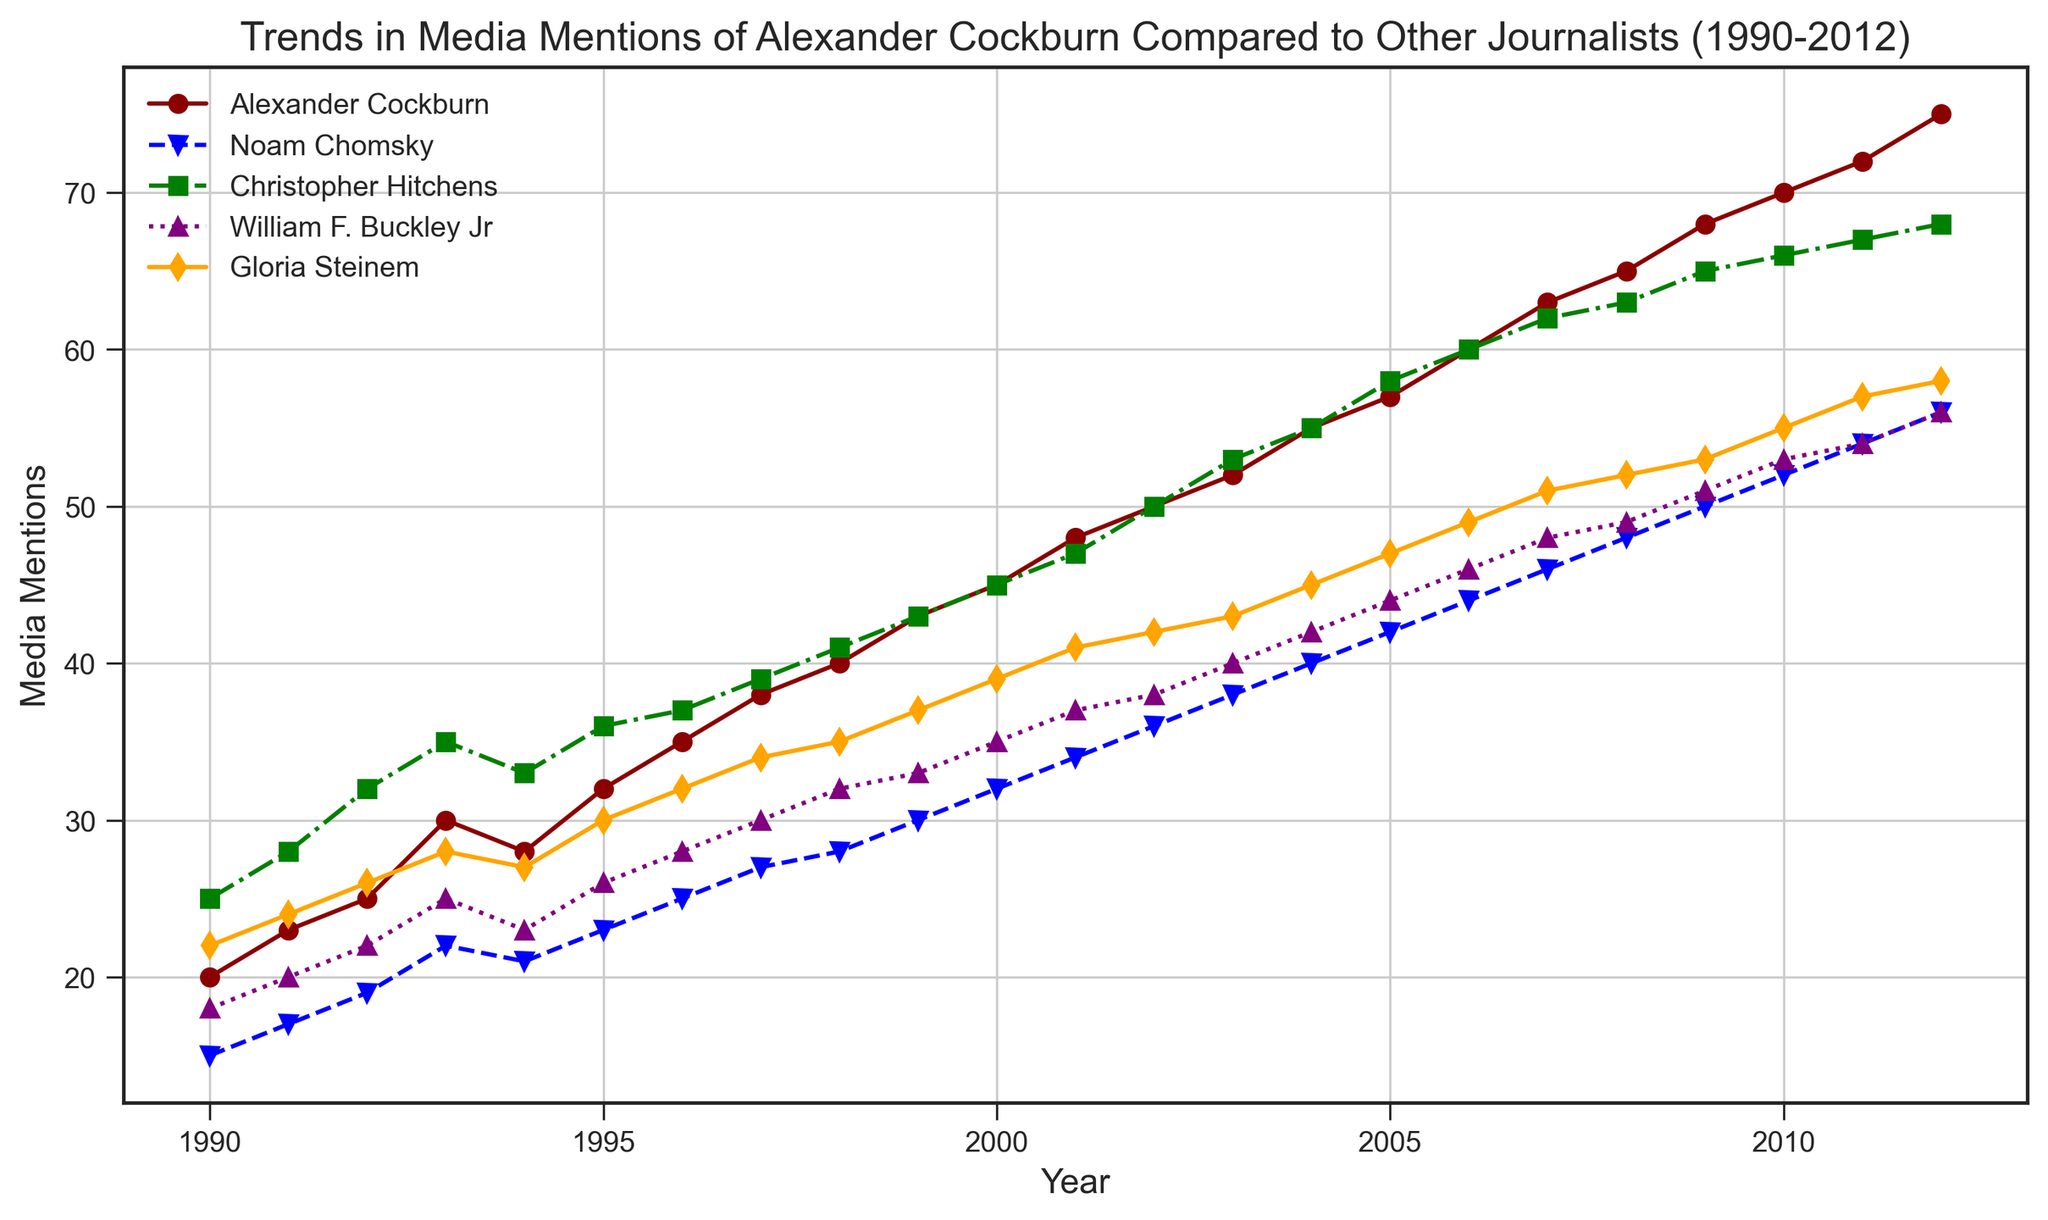What was the trend in media mentions for Alexander Cockburn over the period 1990-2012? Look at the red line representing Alexander Cockburn; it shows a consistent upward trend from 1990 to 2012.
Answer: Consistent upward trend In which year did Christopher Hitchens have the same number of media mentions as Alexander Cockburn? Locate the points on the graph where the green line (Christopher Hitchens) and the red line (Alexander Cockburn) intersect. This occurs around the year 2008.
Answer: 2008 Who had the most media mentions in 2002 among the journalists listed? Refer to the heights of the lines for the year 2002. Alexander Cockburn has the highest point compared to others.
Answer: Alexander Cockburn Compare the media mentions of Noam Chomsky and Gloria Steinem in 2010. Who had more mentions and by how much? Look at the points for 2010 on the blue line (Noam Chomsky) and the orange line (Gloria Steinem). Subtract Chomsky’s mentions from Steinem’s: 55 - 52 = 3. Steinem had more mentions.
Answer: Gloria Steinem, by 3 Calculate the average number of media mentions per year for William F. Buckley Jr. from 1990 to 1995. Sum the values for William F. Buckley Jr. from 1990 to 1995: 18 + 20 + 22 + 25 + 23 + 26 = 134. Divide by 6: 134 / 6 = 22.33.
Answer: 22.33 Who had consistently increasing media mentions every year from 1990 to 2012? Check each line to see who had a consistent upward trend in every year. Alexander Cockburn is the journalist with consistently increasing mentions.
Answer: Alexander Cockburn By how much did Alexander Cockburn’s media mentions increase from 1996 to 2006? Subtract the value in 1996 from the value in 2006 for Alexander Cockburn: 60 - 35 = 25.
Answer: 25 Which journalist showed the least increase in media mentions from 1990 to 2012? Calculate the difference for each journalist between 2012 and 1990: Cockburn (75-20=55), Chomsky (56-15=41), Hitchens (68-25=43), Buckley (56-18=38), Steinem (58-22=36). William F. Buckley Jr. had the least increase.
Answer: William F. Buckley Jr In what year did Gloria Steinem’s media mentions first surpass 40? Look for the first year where the orange line for Gloria Steinem is above 40. This occurs in the year 2004.
Answer: 2004 What is the maximum difference in media mentions between any two journalists in 2005? Check the values for all journalists in 2005: Cockburn (57), Chomsky (42), Hitchens (58), Buckley (44), Steinem (47). The biggest difference is between Hitchens and Chomsky: 58 - 42 = 16.
Answer: 16 